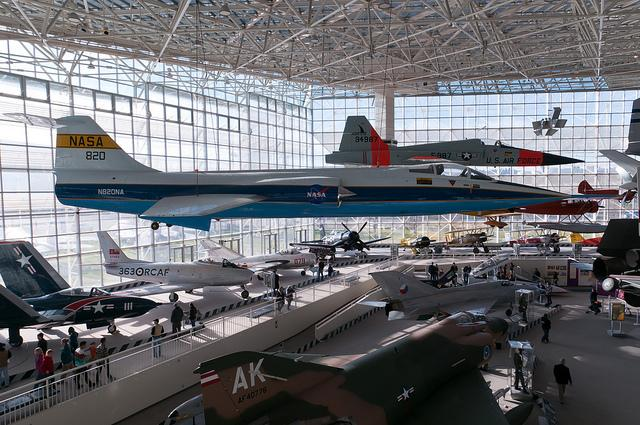What type of transportation is shown? jet 